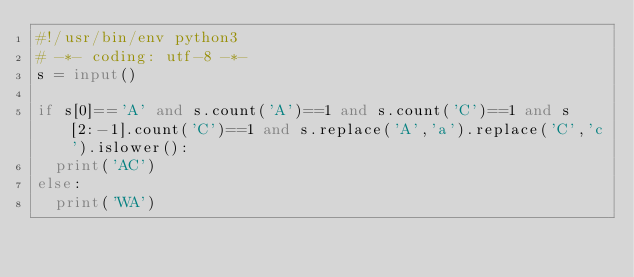<code> <loc_0><loc_0><loc_500><loc_500><_Python_>#!/usr/bin/env python3
# -*- coding: utf-8 -*-
s = input()

if s[0]=='A' and s.count('A')==1 and s.count('C')==1 and s[2:-1].count('C')==1 and s.replace('A','a').replace('C','c').islower():
  print('AC')
else:
  print('WA')
  
</code> 